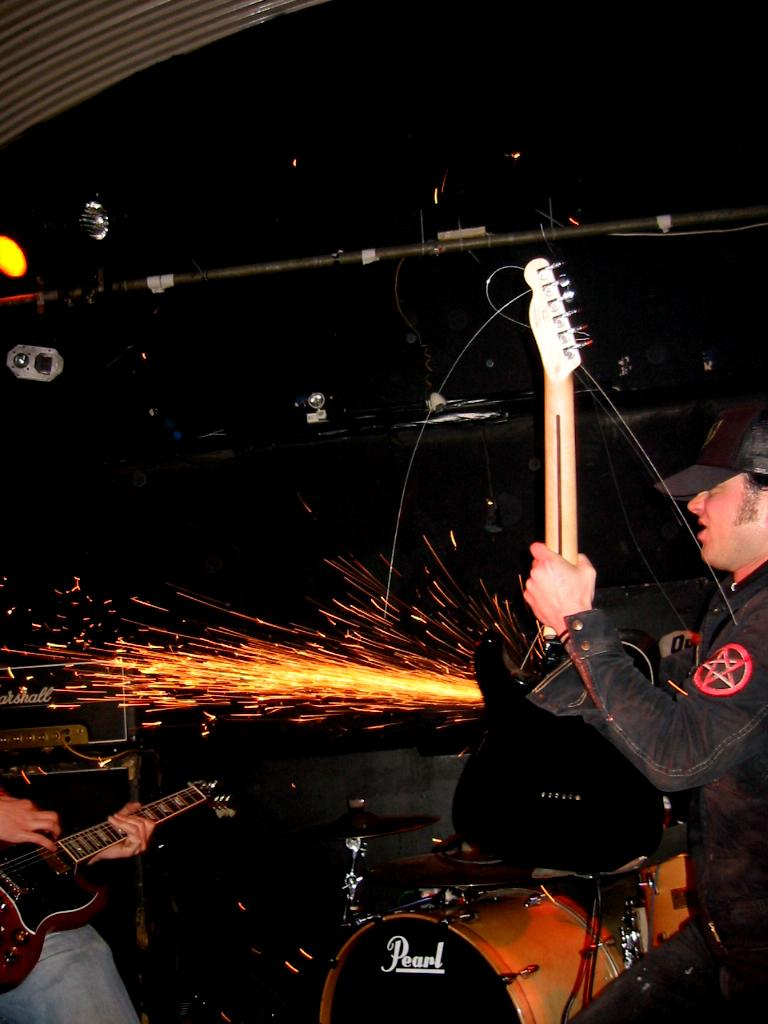What are the persons in the image doing with the guitars? The persons in the image are playing the guitars. What other musical instrument can be seen in the image? There are drums in the image. Can you describe the fire in the image? There is a fire in the image, but its size or purpose is not specified. How is the background of the image characterized? The background of the image is dark. What type of lighting is present in the image? There are lights in the image. Are there any books or a library visible in the image? No, there are no books or library present in the image. How many spiders can be seen crawling on the drums in the image? There are no spiders visible in the image; it features persons playing guitars and drums, a fire, and lights. What color is the sock worn by the person playing the guitar in the image? There is no mention of a sock or any clothing worn by the persons in the image. 